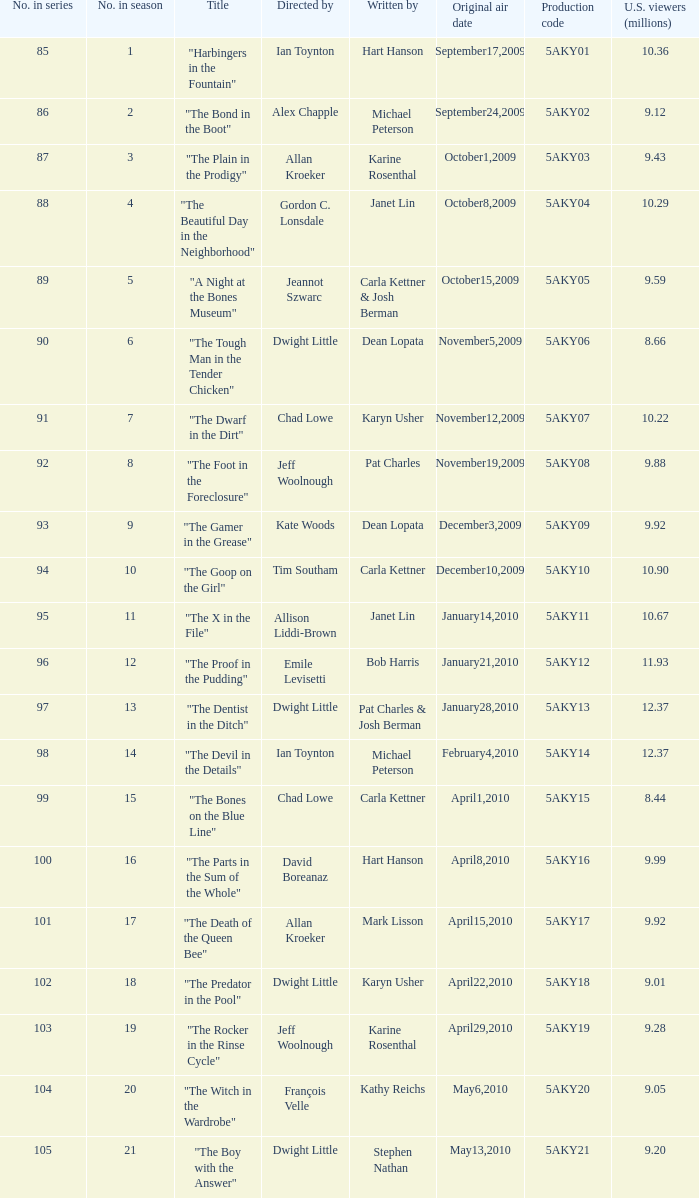Which writer was responsible for the episode with the production code 5aky04? Janet Lin. 